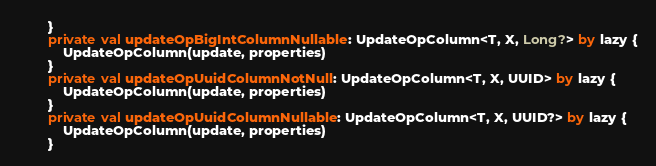Convert code to text. <code><loc_0><loc_0><loc_500><loc_500><_Kotlin_>        }
        private val updateOpBigIntColumnNullable: UpdateOpColumn<T, X, Long?> by lazy {
            UpdateOpColumn(update, properties)
        }
        private val updateOpUuidColumnNotNull: UpdateOpColumn<T, X, UUID> by lazy {
            UpdateOpColumn(update, properties)
        }
        private val updateOpUuidColumnNullable: UpdateOpColumn<T, X, UUID?> by lazy {
            UpdateOpColumn(update, properties)
        }
</code> 